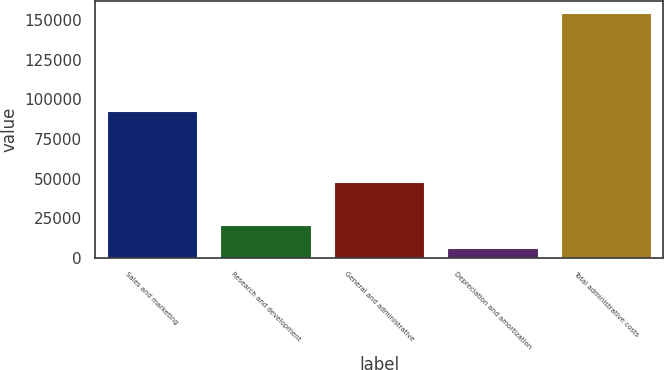Convert chart. <chart><loc_0><loc_0><loc_500><loc_500><bar_chart><fcel>Sales and marketing<fcel>Research and development<fcel>General and administrative<fcel>Depreciation and amortization<fcel>Total administrative costs<nl><fcel>92554<fcel>20638.7<fcel>47826<fcel>5738<fcel>154745<nl></chart> 